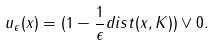<formula> <loc_0><loc_0><loc_500><loc_500>u _ { \epsilon } ( x ) = ( 1 - \frac { 1 } { \epsilon } d i s t ( x , K ) ) \vee 0 .</formula> 